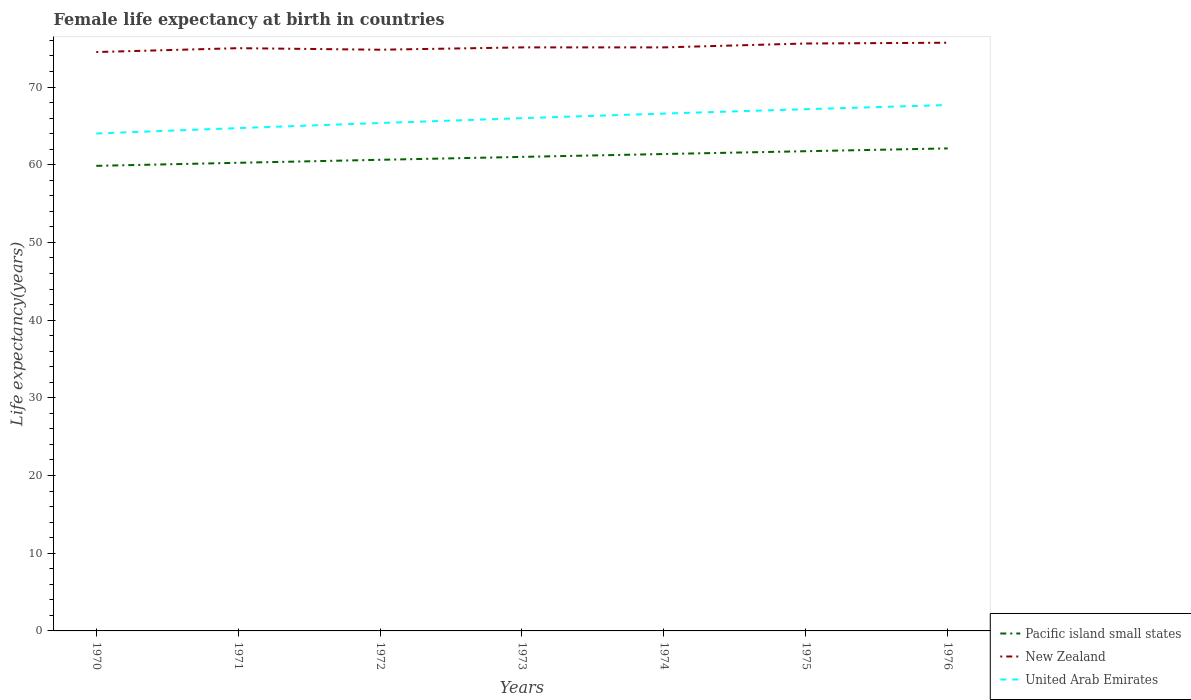Is the number of lines equal to the number of legend labels?
Offer a terse response. Yes. Across all years, what is the maximum female life expectancy at birth in New Zealand?
Provide a short and direct response. 74.5. In which year was the female life expectancy at birth in United Arab Emirates maximum?
Provide a short and direct response. 1970. What is the total female life expectancy at birth in New Zealand in the graph?
Your answer should be compact. -0.3. What is the difference between the highest and the second highest female life expectancy at birth in Pacific island small states?
Your response must be concise. 2.24. What is the difference between the highest and the lowest female life expectancy at birth in United Arab Emirates?
Make the answer very short. 4. How many years are there in the graph?
Your answer should be very brief. 7. What is the difference between two consecutive major ticks on the Y-axis?
Give a very brief answer. 10. Are the values on the major ticks of Y-axis written in scientific E-notation?
Provide a short and direct response. No. Where does the legend appear in the graph?
Offer a very short reply. Bottom right. How are the legend labels stacked?
Your answer should be very brief. Vertical. What is the title of the graph?
Provide a succinct answer. Female life expectancy at birth in countries. Does "Malaysia" appear as one of the legend labels in the graph?
Your response must be concise. No. What is the label or title of the Y-axis?
Offer a terse response. Life expectancy(years). What is the Life expectancy(years) in Pacific island small states in 1970?
Provide a short and direct response. 59.85. What is the Life expectancy(years) of New Zealand in 1970?
Provide a short and direct response. 74.5. What is the Life expectancy(years) in United Arab Emirates in 1970?
Offer a terse response. 64.02. What is the Life expectancy(years) in Pacific island small states in 1971?
Make the answer very short. 60.25. What is the Life expectancy(years) in United Arab Emirates in 1971?
Keep it short and to the point. 64.72. What is the Life expectancy(years) of Pacific island small states in 1972?
Provide a succinct answer. 60.63. What is the Life expectancy(years) in New Zealand in 1972?
Your answer should be very brief. 74.8. What is the Life expectancy(years) in United Arab Emirates in 1972?
Offer a very short reply. 65.37. What is the Life expectancy(years) in Pacific island small states in 1973?
Make the answer very short. 61.01. What is the Life expectancy(years) of New Zealand in 1973?
Offer a very short reply. 75.1. What is the Life expectancy(years) of United Arab Emirates in 1973?
Offer a very short reply. 65.99. What is the Life expectancy(years) in Pacific island small states in 1974?
Your response must be concise. 61.38. What is the Life expectancy(years) in New Zealand in 1974?
Make the answer very short. 75.1. What is the Life expectancy(years) in United Arab Emirates in 1974?
Your answer should be very brief. 66.58. What is the Life expectancy(years) of Pacific island small states in 1975?
Ensure brevity in your answer.  61.74. What is the Life expectancy(years) in New Zealand in 1975?
Give a very brief answer. 75.6. What is the Life expectancy(years) of United Arab Emirates in 1975?
Your answer should be very brief. 67.15. What is the Life expectancy(years) in Pacific island small states in 1976?
Keep it short and to the point. 62.1. What is the Life expectancy(years) of New Zealand in 1976?
Offer a very short reply. 75.7. What is the Life expectancy(years) of United Arab Emirates in 1976?
Provide a succinct answer. 67.69. Across all years, what is the maximum Life expectancy(years) of Pacific island small states?
Your answer should be compact. 62.1. Across all years, what is the maximum Life expectancy(years) in New Zealand?
Offer a terse response. 75.7. Across all years, what is the maximum Life expectancy(years) in United Arab Emirates?
Offer a terse response. 67.69. Across all years, what is the minimum Life expectancy(years) of Pacific island small states?
Keep it short and to the point. 59.85. Across all years, what is the minimum Life expectancy(years) of New Zealand?
Offer a very short reply. 74.5. Across all years, what is the minimum Life expectancy(years) of United Arab Emirates?
Provide a short and direct response. 64.02. What is the total Life expectancy(years) in Pacific island small states in the graph?
Keep it short and to the point. 426.96. What is the total Life expectancy(years) in New Zealand in the graph?
Ensure brevity in your answer.  525.8. What is the total Life expectancy(years) of United Arab Emirates in the graph?
Keep it short and to the point. 461.51. What is the difference between the Life expectancy(years) in Pacific island small states in 1970 and that in 1971?
Provide a short and direct response. -0.39. What is the difference between the Life expectancy(years) of United Arab Emirates in 1970 and that in 1971?
Your response must be concise. -0.69. What is the difference between the Life expectancy(years) of Pacific island small states in 1970 and that in 1972?
Make the answer very short. -0.78. What is the difference between the Life expectancy(years) in United Arab Emirates in 1970 and that in 1972?
Your answer should be very brief. -1.35. What is the difference between the Life expectancy(years) of Pacific island small states in 1970 and that in 1973?
Make the answer very short. -1.15. What is the difference between the Life expectancy(years) of New Zealand in 1970 and that in 1973?
Your answer should be very brief. -0.6. What is the difference between the Life expectancy(years) of United Arab Emirates in 1970 and that in 1973?
Provide a succinct answer. -1.97. What is the difference between the Life expectancy(years) in Pacific island small states in 1970 and that in 1974?
Your response must be concise. -1.52. What is the difference between the Life expectancy(years) of New Zealand in 1970 and that in 1974?
Make the answer very short. -0.6. What is the difference between the Life expectancy(years) in United Arab Emirates in 1970 and that in 1974?
Offer a terse response. -2.56. What is the difference between the Life expectancy(years) of Pacific island small states in 1970 and that in 1975?
Give a very brief answer. -1.88. What is the difference between the Life expectancy(years) of United Arab Emirates in 1970 and that in 1975?
Your answer should be very brief. -3.13. What is the difference between the Life expectancy(years) of Pacific island small states in 1970 and that in 1976?
Your answer should be compact. -2.24. What is the difference between the Life expectancy(years) in New Zealand in 1970 and that in 1976?
Offer a very short reply. -1.2. What is the difference between the Life expectancy(years) in United Arab Emirates in 1970 and that in 1976?
Provide a short and direct response. -3.67. What is the difference between the Life expectancy(years) of Pacific island small states in 1971 and that in 1972?
Your answer should be compact. -0.38. What is the difference between the Life expectancy(years) in United Arab Emirates in 1971 and that in 1972?
Ensure brevity in your answer.  -0.65. What is the difference between the Life expectancy(years) in Pacific island small states in 1971 and that in 1973?
Your answer should be compact. -0.76. What is the difference between the Life expectancy(years) in New Zealand in 1971 and that in 1973?
Your answer should be very brief. -0.1. What is the difference between the Life expectancy(years) in United Arab Emirates in 1971 and that in 1973?
Make the answer very short. -1.28. What is the difference between the Life expectancy(years) in Pacific island small states in 1971 and that in 1974?
Offer a terse response. -1.13. What is the difference between the Life expectancy(years) in New Zealand in 1971 and that in 1974?
Your answer should be compact. -0.1. What is the difference between the Life expectancy(years) of United Arab Emirates in 1971 and that in 1974?
Make the answer very short. -1.87. What is the difference between the Life expectancy(years) in Pacific island small states in 1971 and that in 1975?
Make the answer very short. -1.49. What is the difference between the Life expectancy(years) in New Zealand in 1971 and that in 1975?
Your response must be concise. -0.6. What is the difference between the Life expectancy(years) in United Arab Emirates in 1971 and that in 1975?
Offer a terse response. -2.43. What is the difference between the Life expectancy(years) of Pacific island small states in 1971 and that in 1976?
Your response must be concise. -1.85. What is the difference between the Life expectancy(years) in New Zealand in 1971 and that in 1976?
Offer a terse response. -0.7. What is the difference between the Life expectancy(years) in United Arab Emirates in 1971 and that in 1976?
Your response must be concise. -2.97. What is the difference between the Life expectancy(years) of Pacific island small states in 1972 and that in 1973?
Give a very brief answer. -0.38. What is the difference between the Life expectancy(years) of New Zealand in 1972 and that in 1973?
Give a very brief answer. -0.3. What is the difference between the Life expectancy(years) in United Arab Emirates in 1972 and that in 1973?
Your answer should be very brief. -0.62. What is the difference between the Life expectancy(years) of Pacific island small states in 1972 and that in 1974?
Make the answer very short. -0.74. What is the difference between the Life expectancy(years) in United Arab Emirates in 1972 and that in 1974?
Ensure brevity in your answer.  -1.21. What is the difference between the Life expectancy(years) of Pacific island small states in 1972 and that in 1975?
Provide a succinct answer. -1.11. What is the difference between the Life expectancy(years) in New Zealand in 1972 and that in 1975?
Provide a succinct answer. -0.8. What is the difference between the Life expectancy(years) in United Arab Emirates in 1972 and that in 1975?
Provide a short and direct response. -1.78. What is the difference between the Life expectancy(years) in Pacific island small states in 1972 and that in 1976?
Provide a succinct answer. -1.47. What is the difference between the Life expectancy(years) of New Zealand in 1972 and that in 1976?
Your response must be concise. -0.9. What is the difference between the Life expectancy(years) of United Arab Emirates in 1972 and that in 1976?
Ensure brevity in your answer.  -2.32. What is the difference between the Life expectancy(years) of Pacific island small states in 1973 and that in 1974?
Offer a terse response. -0.37. What is the difference between the Life expectancy(years) in United Arab Emirates in 1973 and that in 1974?
Give a very brief answer. -0.59. What is the difference between the Life expectancy(years) of Pacific island small states in 1973 and that in 1975?
Your answer should be very brief. -0.73. What is the difference between the Life expectancy(years) in New Zealand in 1973 and that in 1975?
Provide a succinct answer. -0.5. What is the difference between the Life expectancy(years) in United Arab Emirates in 1973 and that in 1975?
Offer a very short reply. -1.16. What is the difference between the Life expectancy(years) in Pacific island small states in 1973 and that in 1976?
Give a very brief answer. -1.09. What is the difference between the Life expectancy(years) in United Arab Emirates in 1973 and that in 1976?
Offer a very short reply. -1.69. What is the difference between the Life expectancy(years) in Pacific island small states in 1974 and that in 1975?
Provide a short and direct response. -0.36. What is the difference between the Life expectancy(years) in New Zealand in 1974 and that in 1975?
Your answer should be very brief. -0.5. What is the difference between the Life expectancy(years) of United Arab Emirates in 1974 and that in 1975?
Provide a short and direct response. -0.56. What is the difference between the Life expectancy(years) in Pacific island small states in 1974 and that in 1976?
Your response must be concise. -0.72. What is the difference between the Life expectancy(years) of New Zealand in 1974 and that in 1976?
Offer a very short reply. -0.6. What is the difference between the Life expectancy(years) in United Arab Emirates in 1974 and that in 1976?
Keep it short and to the point. -1.1. What is the difference between the Life expectancy(years) in Pacific island small states in 1975 and that in 1976?
Make the answer very short. -0.36. What is the difference between the Life expectancy(years) of United Arab Emirates in 1975 and that in 1976?
Provide a succinct answer. -0.54. What is the difference between the Life expectancy(years) of Pacific island small states in 1970 and the Life expectancy(years) of New Zealand in 1971?
Provide a short and direct response. -15.15. What is the difference between the Life expectancy(years) in Pacific island small states in 1970 and the Life expectancy(years) in United Arab Emirates in 1971?
Your answer should be very brief. -4.86. What is the difference between the Life expectancy(years) in New Zealand in 1970 and the Life expectancy(years) in United Arab Emirates in 1971?
Give a very brief answer. 9.79. What is the difference between the Life expectancy(years) in Pacific island small states in 1970 and the Life expectancy(years) in New Zealand in 1972?
Ensure brevity in your answer.  -14.95. What is the difference between the Life expectancy(years) of Pacific island small states in 1970 and the Life expectancy(years) of United Arab Emirates in 1972?
Offer a very short reply. -5.51. What is the difference between the Life expectancy(years) of New Zealand in 1970 and the Life expectancy(years) of United Arab Emirates in 1972?
Provide a short and direct response. 9.13. What is the difference between the Life expectancy(years) in Pacific island small states in 1970 and the Life expectancy(years) in New Zealand in 1973?
Your answer should be very brief. -15.25. What is the difference between the Life expectancy(years) in Pacific island small states in 1970 and the Life expectancy(years) in United Arab Emirates in 1973?
Your response must be concise. -6.14. What is the difference between the Life expectancy(years) in New Zealand in 1970 and the Life expectancy(years) in United Arab Emirates in 1973?
Provide a short and direct response. 8.51. What is the difference between the Life expectancy(years) of Pacific island small states in 1970 and the Life expectancy(years) of New Zealand in 1974?
Offer a terse response. -15.25. What is the difference between the Life expectancy(years) of Pacific island small states in 1970 and the Life expectancy(years) of United Arab Emirates in 1974?
Provide a succinct answer. -6.73. What is the difference between the Life expectancy(years) in New Zealand in 1970 and the Life expectancy(years) in United Arab Emirates in 1974?
Your answer should be very brief. 7.92. What is the difference between the Life expectancy(years) in Pacific island small states in 1970 and the Life expectancy(years) in New Zealand in 1975?
Offer a terse response. -15.75. What is the difference between the Life expectancy(years) in Pacific island small states in 1970 and the Life expectancy(years) in United Arab Emirates in 1975?
Provide a short and direct response. -7.29. What is the difference between the Life expectancy(years) in New Zealand in 1970 and the Life expectancy(years) in United Arab Emirates in 1975?
Provide a succinct answer. 7.35. What is the difference between the Life expectancy(years) in Pacific island small states in 1970 and the Life expectancy(years) in New Zealand in 1976?
Keep it short and to the point. -15.85. What is the difference between the Life expectancy(years) in Pacific island small states in 1970 and the Life expectancy(years) in United Arab Emirates in 1976?
Your response must be concise. -7.83. What is the difference between the Life expectancy(years) of New Zealand in 1970 and the Life expectancy(years) of United Arab Emirates in 1976?
Ensure brevity in your answer.  6.82. What is the difference between the Life expectancy(years) in Pacific island small states in 1971 and the Life expectancy(years) in New Zealand in 1972?
Provide a succinct answer. -14.55. What is the difference between the Life expectancy(years) of Pacific island small states in 1971 and the Life expectancy(years) of United Arab Emirates in 1972?
Provide a short and direct response. -5.12. What is the difference between the Life expectancy(years) of New Zealand in 1971 and the Life expectancy(years) of United Arab Emirates in 1972?
Ensure brevity in your answer.  9.63. What is the difference between the Life expectancy(years) in Pacific island small states in 1971 and the Life expectancy(years) in New Zealand in 1973?
Your answer should be very brief. -14.85. What is the difference between the Life expectancy(years) in Pacific island small states in 1971 and the Life expectancy(years) in United Arab Emirates in 1973?
Provide a short and direct response. -5.74. What is the difference between the Life expectancy(years) of New Zealand in 1971 and the Life expectancy(years) of United Arab Emirates in 1973?
Provide a succinct answer. 9.01. What is the difference between the Life expectancy(years) in Pacific island small states in 1971 and the Life expectancy(years) in New Zealand in 1974?
Make the answer very short. -14.85. What is the difference between the Life expectancy(years) of Pacific island small states in 1971 and the Life expectancy(years) of United Arab Emirates in 1974?
Your response must be concise. -6.33. What is the difference between the Life expectancy(years) in New Zealand in 1971 and the Life expectancy(years) in United Arab Emirates in 1974?
Keep it short and to the point. 8.42. What is the difference between the Life expectancy(years) of Pacific island small states in 1971 and the Life expectancy(years) of New Zealand in 1975?
Make the answer very short. -15.35. What is the difference between the Life expectancy(years) in Pacific island small states in 1971 and the Life expectancy(years) in United Arab Emirates in 1975?
Offer a terse response. -6.9. What is the difference between the Life expectancy(years) of New Zealand in 1971 and the Life expectancy(years) of United Arab Emirates in 1975?
Provide a short and direct response. 7.85. What is the difference between the Life expectancy(years) in Pacific island small states in 1971 and the Life expectancy(years) in New Zealand in 1976?
Provide a short and direct response. -15.45. What is the difference between the Life expectancy(years) of Pacific island small states in 1971 and the Life expectancy(years) of United Arab Emirates in 1976?
Give a very brief answer. -7.44. What is the difference between the Life expectancy(years) of New Zealand in 1971 and the Life expectancy(years) of United Arab Emirates in 1976?
Ensure brevity in your answer.  7.32. What is the difference between the Life expectancy(years) of Pacific island small states in 1972 and the Life expectancy(years) of New Zealand in 1973?
Your answer should be very brief. -14.47. What is the difference between the Life expectancy(years) in Pacific island small states in 1972 and the Life expectancy(years) in United Arab Emirates in 1973?
Keep it short and to the point. -5.36. What is the difference between the Life expectancy(years) of New Zealand in 1972 and the Life expectancy(years) of United Arab Emirates in 1973?
Offer a very short reply. 8.81. What is the difference between the Life expectancy(years) in Pacific island small states in 1972 and the Life expectancy(years) in New Zealand in 1974?
Keep it short and to the point. -14.47. What is the difference between the Life expectancy(years) of Pacific island small states in 1972 and the Life expectancy(years) of United Arab Emirates in 1974?
Keep it short and to the point. -5.95. What is the difference between the Life expectancy(years) in New Zealand in 1972 and the Life expectancy(years) in United Arab Emirates in 1974?
Give a very brief answer. 8.22. What is the difference between the Life expectancy(years) of Pacific island small states in 1972 and the Life expectancy(years) of New Zealand in 1975?
Your answer should be compact. -14.97. What is the difference between the Life expectancy(years) in Pacific island small states in 1972 and the Life expectancy(years) in United Arab Emirates in 1975?
Provide a short and direct response. -6.51. What is the difference between the Life expectancy(years) of New Zealand in 1972 and the Life expectancy(years) of United Arab Emirates in 1975?
Your answer should be very brief. 7.65. What is the difference between the Life expectancy(years) of Pacific island small states in 1972 and the Life expectancy(years) of New Zealand in 1976?
Give a very brief answer. -15.07. What is the difference between the Life expectancy(years) of Pacific island small states in 1972 and the Life expectancy(years) of United Arab Emirates in 1976?
Give a very brief answer. -7.05. What is the difference between the Life expectancy(years) of New Zealand in 1972 and the Life expectancy(years) of United Arab Emirates in 1976?
Keep it short and to the point. 7.12. What is the difference between the Life expectancy(years) in Pacific island small states in 1973 and the Life expectancy(years) in New Zealand in 1974?
Your answer should be very brief. -14.09. What is the difference between the Life expectancy(years) in Pacific island small states in 1973 and the Life expectancy(years) in United Arab Emirates in 1974?
Provide a short and direct response. -5.57. What is the difference between the Life expectancy(years) of New Zealand in 1973 and the Life expectancy(years) of United Arab Emirates in 1974?
Make the answer very short. 8.52. What is the difference between the Life expectancy(years) of Pacific island small states in 1973 and the Life expectancy(years) of New Zealand in 1975?
Keep it short and to the point. -14.59. What is the difference between the Life expectancy(years) in Pacific island small states in 1973 and the Life expectancy(years) in United Arab Emirates in 1975?
Your answer should be compact. -6.14. What is the difference between the Life expectancy(years) in New Zealand in 1973 and the Life expectancy(years) in United Arab Emirates in 1975?
Offer a very short reply. 7.95. What is the difference between the Life expectancy(years) in Pacific island small states in 1973 and the Life expectancy(years) in New Zealand in 1976?
Make the answer very short. -14.69. What is the difference between the Life expectancy(years) in Pacific island small states in 1973 and the Life expectancy(years) in United Arab Emirates in 1976?
Offer a terse response. -6.68. What is the difference between the Life expectancy(years) in New Zealand in 1973 and the Life expectancy(years) in United Arab Emirates in 1976?
Provide a succinct answer. 7.42. What is the difference between the Life expectancy(years) in Pacific island small states in 1974 and the Life expectancy(years) in New Zealand in 1975?
Keep it short and to the point. -14.22. What is the difference between the Life expectancy(years) of Pacific island small states in 1974 and the Life expectancy(years) of United Arab Emirates in 1975?
Your answer should be very brief. -5.77. What is the difference between the Life expectancy(years) of New Zealand in 1974 and the Life expectancy(years) of United Arab Emirates in 1975?
Your answer should be very brief. 7.95. What is the difference between the Life expectancy(years) in Pacific island small states in 1974 and the Life expectancy(years) in New Zealand in 1976?
Provide a short and direct response. -14.32. What is the difference between the Life expectancy(years) of Pacific island small states in 1974 and the Life expectancy(years) of United Arab Emirates in 1976?
Provide a short and direct response. -6.31. What is the difference between the Life expectancy(years) in New Zealand in 1974 and the Life expectancy(years) in United Arab Emirates in 1976?
Offer a very short reply. 7.42. What is the difference between the Life expectancy(years) in Pacific island small states in 1975 and the Life expectancy(years) in New Zealand in 1976?
Give a very brief answer. -13.96. What is the difference between the Life expectancy(years) of Pacific island small states in 1975 and the Life expectancy(years) of United Arab Emirates in 1976?
Offer a terse response. -5.95. What is the difference between the Life expectancy(years) of New Zealand in 1975 and the Life expectancy(years) of United Arab Emirates in 1976?
Give a very brief answer. 7.92. What is the average Life expectancy(years) of Pacific island small states per year?
Your answer should be compact. 60.99. What is the average Life expectancy(years) in New Zealand per year?
Your answer should be very brief. 75.11. What is the average Life expectancy(years) of United Arab Emirates per year?
Ensure brevity in your answer.  65.93. In the year 1970, what is the difference between the Life expectancy(years) of Pacific island small states and Life expectancy(years) of New Zealand?
Make the answer very short. -14.65. In the year 1970, what is the difference between the Life expectancy(years) of Pacific island small states and Life expectancy(years) of United Arab Emirates?
Provide a succinct answer. -4.17. In the year 1970, what is the difference between the Life expectancy(years) of New Zealand and Life expectancy(years) of United Arab Emirates?
Provide a short and direct response. 10.48. In the year 1971, what is the difference between the Life expectancy(years) in Pacific island small states and Life expectancy(years) in New Zealand?
Provide a short and direct response. -14.75. In the year 1971, what is the difference between the Life expectancy(years) in Pacific island small states and Life expectancy(years) in United Arab Emirates?
Provide a succinct answer. -4.47. In the year 1971, what is the difference between the Life expectancy(years) in New Zealand and Life expectancy(years) in United Arab Emirates?
Ensure brevity in your answer.  10.29. In the year 1972, what is the difference between the Life expectancy(years) in Pacific island small states and Life expectancy(years) in New Zealand?
Offer a very short reply. -14.17. In the year 1972, what is the difference between the Life expectancy(years) of Pacific island small states and Life expectancy(years) of United Arab Emirates?
Ensure brevity in your answer.  -4.74. In the year 1972, what is the difference between the Life expectancy(years) of New Zealand and Life expectancy(years) of United Arab Emirates?
Ensure brevity in your answer.  9.43. In the year 1973, what is the difference between the Life expectancy(years) of Pacific island small states and Life expectancy(years) of New Zealand?
Offer a very short reply. -14.09. In the year 1973, what is the difference between the Life expectancy(years) in Pacific island small states and Life expectancy(years) in United Arab Emirates?
Offer a very short reply. -4.98. In the year 1973, what is the difference between the Life expectancy(years) of New Zealand and Life expectancy(years) of United Arab Emirates?
Your answer should be compact. 9.11. In the year 1974, what is the difference between the Life expectancy(years) in Pacific island small states and Life expectancy(years) in New Zealand?
Give a very brief answer. -13.72. In the year 1974, what is the difference between the Life expectancy(years) in Pacific island small states and Life expectancy(years) in United Arab Emirates?
Your response must be concise. -5.21. In the year 1974, what is the difference between the Life expectancy(years) of New Zealand and Life expectancy(years) of United Arab Emirates?
Make the answer very short. 8.52. In the year 1975, what is the difference between the Life expectancy(years) of Pacific island small states and Life expectancy(years) of New Zealand?
Give a very brief answer. -13.86. In the year 1975, what is the difference between the Life expectancy(years) in Pacific island small states and Life expectancy(years) in United Arab Emirates?
Ensure brevity in your answer.  -5.41. In the year 1975, what is the difference between the Life expectancy(years) of New Zealand and Life expectancy(years) of United Arab Emirates?
Provide a short and direct response. 8.45. In the year 1976, what is the difference between the Life expectancy(years) of Pacific island small states and Life expectancy(years) of New Zealand?
Give a very brief answer. -13.6. In the year 1976, what is the difference between the Life expectancy(years) in Pacific island small states and Life expectancy(years) in United Arab Emirates?
Your answer should be very brief. -5.59. In the year 1976, what is the difference between the Life expectancy(years) of New Zealand and Life expectancy(years) of United Arab Emirates?
Offer a terse response. 8.02. What is the ratio of the Life expectancy(years) in United Arab Emirates in 1970 to that in 1971?
Offer a very short reply. 0.99. What is the ratio of the Life expectancy(years) of Pacific island small states in 1970 to that in 1972?
Provide a short and direct response. 0.99. What is the ratio of the Life expectancy(years) of New Zealand in 1970 to that in 1972?
Your response must be concise. 1. What is the ratio of the Life expectancy(years) in United Arab Emirates in 1970 to that in 1972?
Your answer should be very brief. 0.98. What is the ratio of the Life expectancy(years) in Pacific island small states in 1970 to that in 1973?
Give a very brief answer. 0.98. What is the ratio of the Life expectancy(years) of New Zealand in 1970 to that in 1973?
Make the answer very short. 0.99. What is the ratio of the Life expectancy(years) of United Arab Emirates in 1970 to that in 1973?
Offer a terse response. 0.97. What is the ratio of the Life expectancy(years) in Pacific island small states in 1970 to that in 1974?
Your answer should be very brief. 0.98. What is the ratio of the Life expectancy(years) in United Arab Emirates in 1970 to that in 1974?
Offer a terse response. 0.96. What is the ratio of the Life expectancy(years) of Pacific island small states in 1970 to that in 1975?
Give a very brief answer. 0.97. What is the ratio of the Life expectancy(years) of New Zealand in 1970 to that in 1975?
Provide a succinct answer. 0.99. What is the ratio of the Life expectancy(years) in United Arab Emirates in 1970 to that in 1975?
Give a very brief answer. 0.95. What is the ratio of the Life expectancy(years) in Pacific island small states in 1970 to that in 1976?
Your answer should be very brief. 0.96. What is the ratio of the Life expectancy(years) in New Zealand in 1970 to that in 1976?
Your answer should be very brief. 0.98. What is the ratio of the Life expectancy(years) in United Arab Emirates in 1970 to that in 1976?
Keep it short and to the point. 0.95. What is the ratio of the Life expectancy(years) of Pacific island small states in 1971 to that in 1972?
Provide a succinct answer. 0.99. What is the ratio of the Life expectancy(years) in New Zealand in 1971 to that in 1972?
Provide a short and direct response. 1. What is the ratio of the Life expectancy(years) in Pacific island small states in 1971 to that in 1973?
Make the answer very short. 0.99. What is the ratio of the Life expectancy(years) of New Zealand in 1971 to that in 1973?
Your answer should be very brief. 1. What is the ratio of the Life expectancy(years) of United Arab Emirates in 1971 to that in 1973?
Your response must be concise. 0.98. What is the ratio of the Life expectancy(years) in Pacific island small states in 1971 to that in 1974?
Make the answer very short. 0.98. What is the ratio of the Life expectancy(years) in New Zealand in 1971 to that in 1974?
Give a very brief answer. 1. What is the ratio of the Life expectancy(years) in United Arab Emirates in 1971 to that in 1974?
Make the answer very short. 0.97. What is the ratio of the Life expectancy(years) in Pacific island small states in 1971 to that in 1975?
Provide a short and direct response. 0.98. What is the ratio of the Life expectancy(years) in New Zealand in 1971 to that in 1975?
Offer a terse response. 0.99. What is the ratio of the Life expectancy(years) in United Arab Emirates in 1971 to that in 1975?
Keep it short and to the point. 0.96. What is the ratio of the Life expectancy(years) in Pacific island small states in 1971 to that in 1976?
Ensure brevity in your answer.  0.97. What is the ratio of the Life expectancy(years) of United Arab Emirates in 1971 to that in 1976?
Ensure brevity in your answer.  0.96. What is the ratio of the Life expectancy(years) of Pacific island small states in 1972 to that in 1973?
Your answer should be very brief. 0.99. What is the ratio of the Life expectancy(years) in New Zealand in 1972 to that in 1973?
Offer a terse response. 1. What is the ratio of the Life expectancy(years) of United Arab Emirates in 1972 to that in 1973?
Give a very brief answer. 0.99. What is the ratio of the Life expectancy(years) of Pacific island small states in 1972 to that in 1974?
Offer a very short reply. 0.99. What is the ratio of the Life expectancy(years) in United Arab Emirates in 1972 to that in 1974?
Your response must be concise. 0.98. What is the ratio of the Life expectancy(years) of Pacific island small states in 1972 to that in 1975?
Your answer should be very brief. 0.98. What is the ratio of the Life expectancy(years) in New Zealand in 1972 to that in 1975?
Ensure brevity in your answer.  0.99. What is the ratio of the Life expectancy(years) in United Arab Emirates in 1972 to that in 1975?
Offer a very short reply. 0.97. What is the ratio of the Life expectancy(years) of Pacific island small states in 1972 to that in 1976?
Keep it short and to the point. 0.98. What is the ratio of the Life expectancy(years) in New Zealand in 1972 to that in 1976?
Keep it short and to the point. 0.99. What is the ratio of the Life expectancy(years) of United Arab Emirates in 1972 to that in 1976?
Offer a very short reply. 0.97. What is the ratio of the Life expectancy(years) in New Zealand in 1973 to that in 1974?
Provide a short and direct response. 1. What is the ratio of the Life expectancy(years) of United Arab Emirates in 1973 to that in 1974?
Provide a succinct answer. 0.99. What is the ratio of the Life expectancy(years) of New Zealand in 1973 to that in 1975?
Your response must be concise. 0.99. What is the ratio of the Life expectancy(years) in United Arab Emirates in 1973 to that in 1975?
Give a very brief answer. 0.98. What is the ratio of the Life expectancy(years) of Pacific island small states in 1973 to that in 1976?
Keep it short and to the point. 0.98. What is the ratio of the Life expectancy(years) in New Zealand in 1973 to that in 1976?
Your response must be concise. 0.99. What is the ratio of the Life expectancy(years) of United Arab Emirates in 1973 to that in 1976?
Your answer should be very brief. 0.97. What is the ratio of the Life expectancy(years) of Pacific island small states in 1974 to that in 1976?
Your response must be concise. 0.99. What is the ratio of the Life expectancy(years) of New Zealand in 1974 to that in 1976?
Offer a terse response. 0.99. What is the ratio of the Life expectancy(years) of United Arab Emirates in 1974 to that in 1976?
Your answer should be compact. 0.98. What is the ratio of the Life expectancy(years) of Pacific island small states in 1975 to that in 1976?
Ensure brevity in your answer.  0.99. What is the ratio of the Life expectancy(years) of New Zealand in 1975 to that in 1976?
Make the answer very short. 1. What is the ratio of the Life expectancy(years) of United Arab Emirates in 1975 to that in 1976?
Your answer should be compact. 0.99. What is the difference between the highest and the second highest Life expectancy(years) in Pacific island small states?
Provide a succinct answer. 0.36. What is the difference between the highest and the second highest Life expectancy(years) of New Zealand?
Give a very brief answer. 0.1. What is the difference between the highest and the second highest Life expectancy(years) of United Arab Emirates?
Your answer should be compact. 0.54. What is the difference between the highest and the lowest Life expectancy(years) of Pacific island small states?
Provide a succinct answer. 2.24. What is the difference between the highest and the lowest Life expectancy(years) of United Arab Emirates?
Provide a short and direct response. 3.67. 